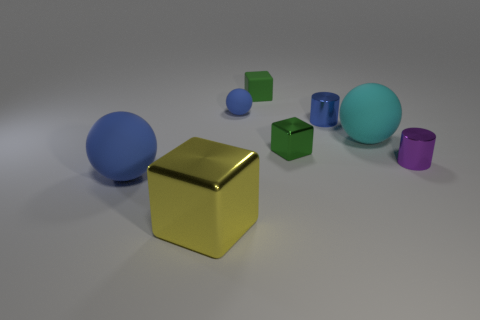Subtract all brown cylinders. How many blue spheres are left? 2 Subtract all big matte spheres. How many spheres are left? 1 Subtract 1 spheres. How many spheres are left? 2 Add 2 large yellow blocks. How many objects exist? 10 Subtract all small metal cubes. Subtract all tiny blue cylinders. How many objects are left? 6 Add 4 blue spheres. How many blue spheres are left? 6 Add 2 yellow matte cubes. How many yellow matte cubes exist? 2 Subtract 1 cyan spheres. How many objects are left? 7 Subtract all cubes. How many objects are left? 5 